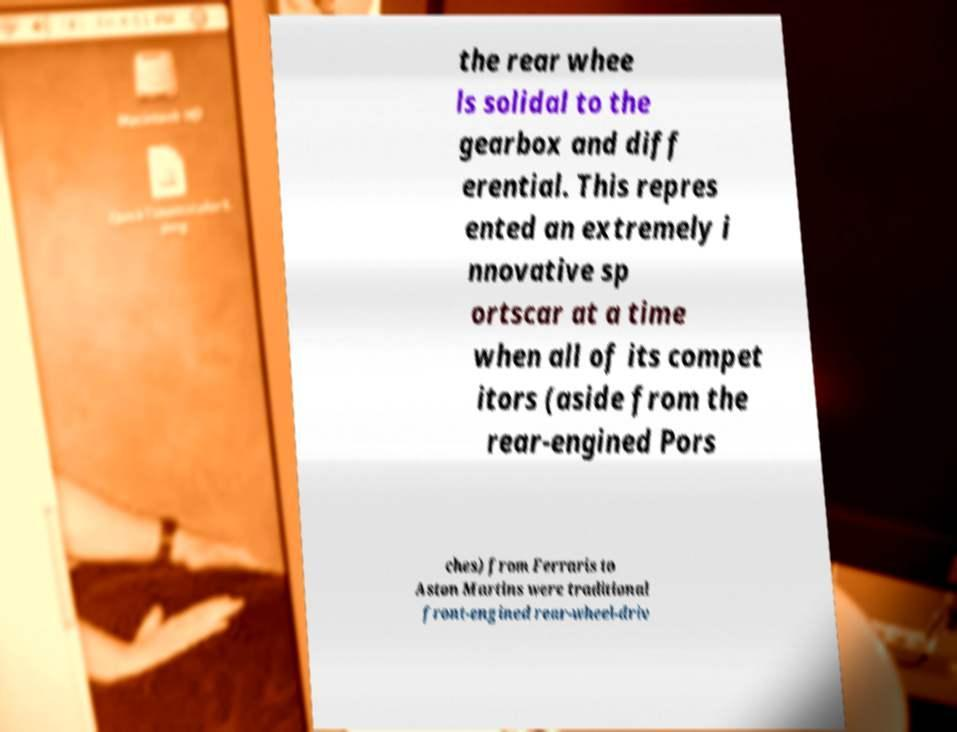Please read and relay the text visible in this image. What does it say? the rear whee ls solidal to the gearbox and diff erential. This repres ented an extremely i nnovative sp ortscar at a time when all of its compet itors (aside from the rear-engined Pors ches) from Ferraris to Aston Martins were traditional front-engined rear-wheel-driv 